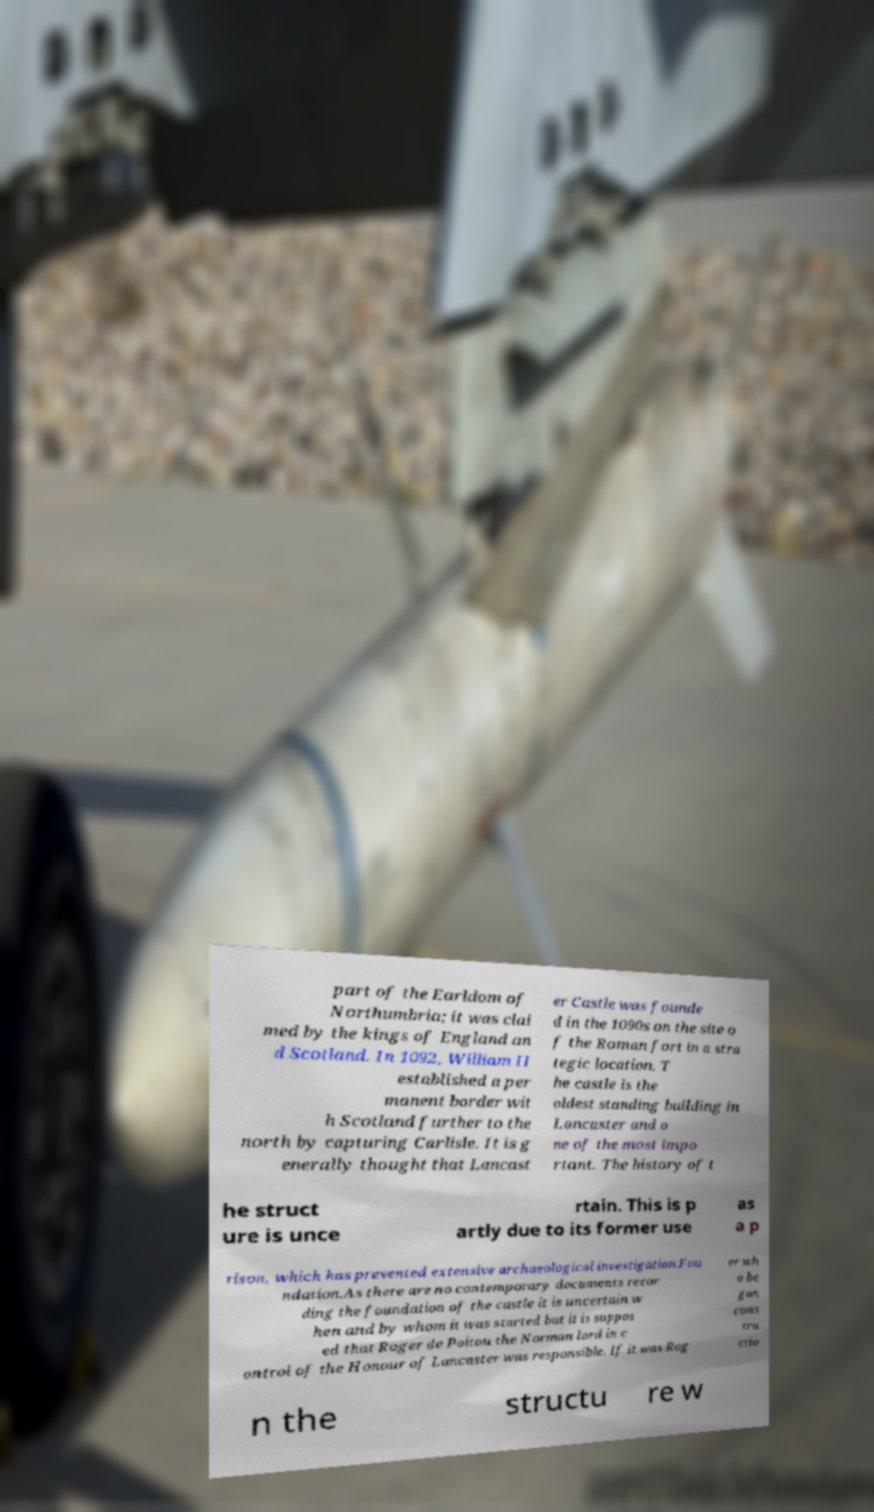Could you extract and type out the text from this image? part of the Earldom of Northumbria; it was clai med by the kings of England an d Scotland. In 1092, William II established a per manent border wit h Scotland further to the north by capturing Carlisle. It is g enerally thought that Lancast er Castle was founde d in the 1090s on the site o f the Roman fort in a stra tegic location. T he castle is the oldest standing building in Lancaster and o ne of the most impo rtant. The history of t he struct ure is unce rtain. This is p artly due to its former use as a p rison, which has prevented extensive archaeological investigation.Fou ndation.As there are no contemporary documents recor ding the foundation of the castle it is uncertain w hen and by whom it was started but it is suppos ed that Roger de Poitou the Norman lord in c ontrol of the Honour of Lancaster was responsible. If it was Rog er wh o be gan cons tru ctio n the structu re w 